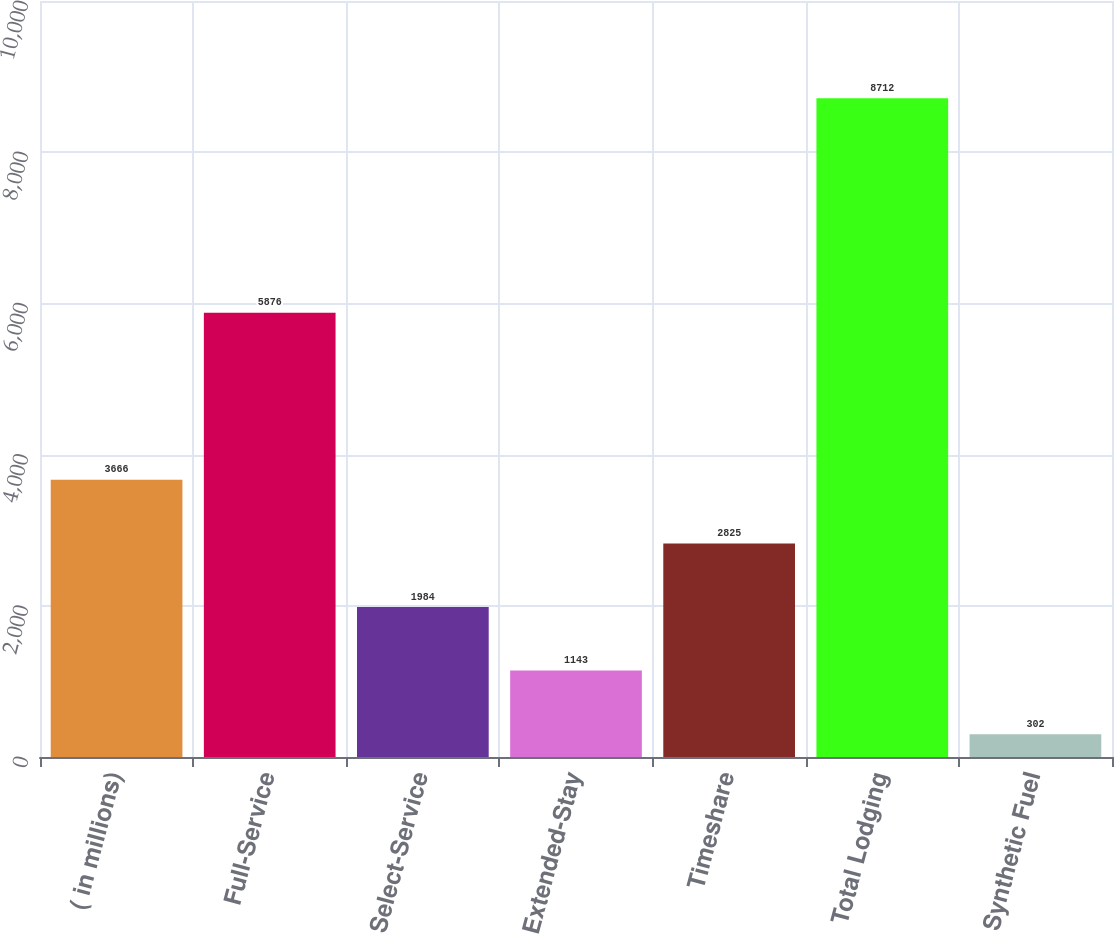Convert chart to OTSL. <chart><loc_0><loc_0><loc_500><loc_500><bar_chart><fcel>( in millions)<fcel>Full-Service<fcel>Select-Service<fcel>Extended-Stay<fcel>Timeshare<fcel>Total Lodging<fcel>Synthetic Fuel<nl><fcel>3666<fcel>5876<fcel>1984<fcel>1143<fcel>2825<fcel>8712<fcel>302<nl></chart> 